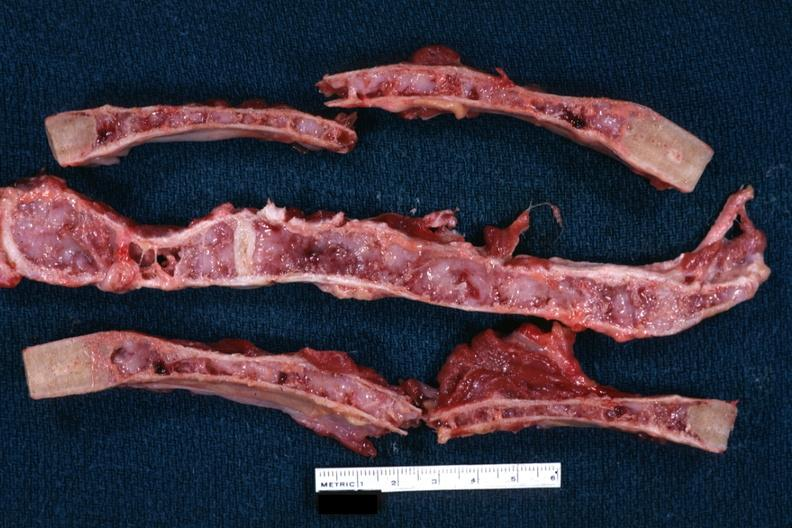what does this image show?
Answer the question using a single word or phrase. Near if not natural color saggital sections very good example of many myeloma lesions 